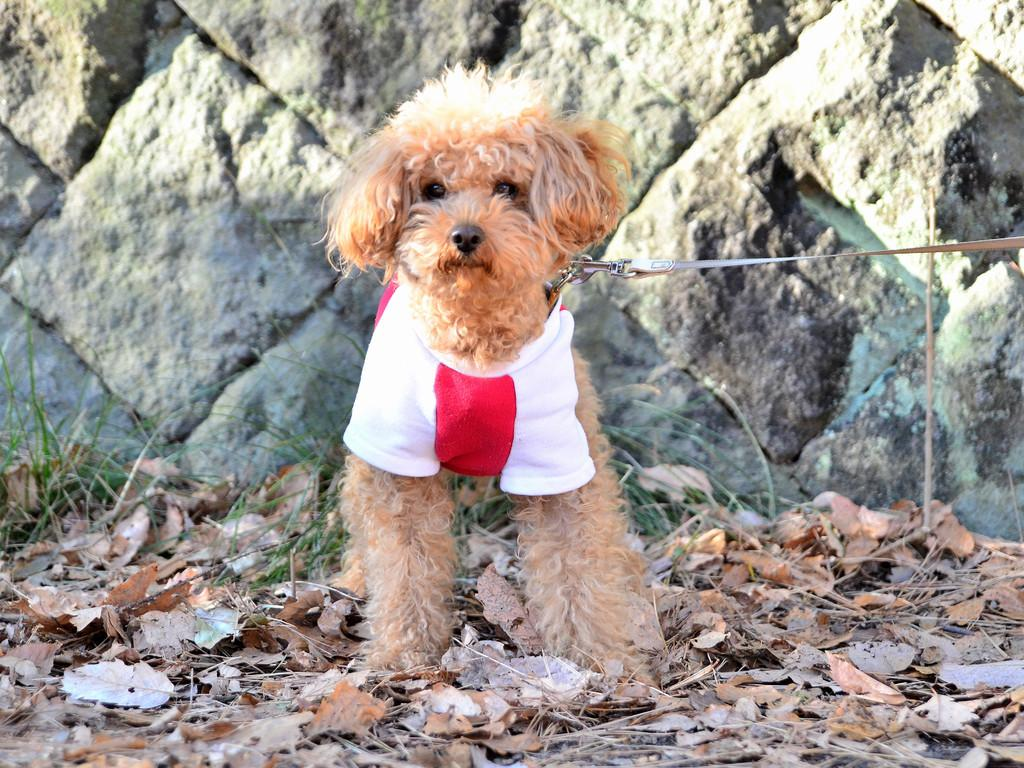What type of animal is present in the image? There is a dog in the image. What color is the dog? The dog is brown in color. What is the dog wearing? The dog is wearing a white and red cloth. Can you describe the cloth the dog is wearing? The cloth has a belt attached to it. What can be seen in the background of the image? There is a wall in the background of the image. What type of representative can be seen in the image? There is no representative present in the image; it features a dog wearing a cloth with a belt. What type of camera is used to capture the image? The type of camera used to capture the image is not mentioned in the provided facts. 